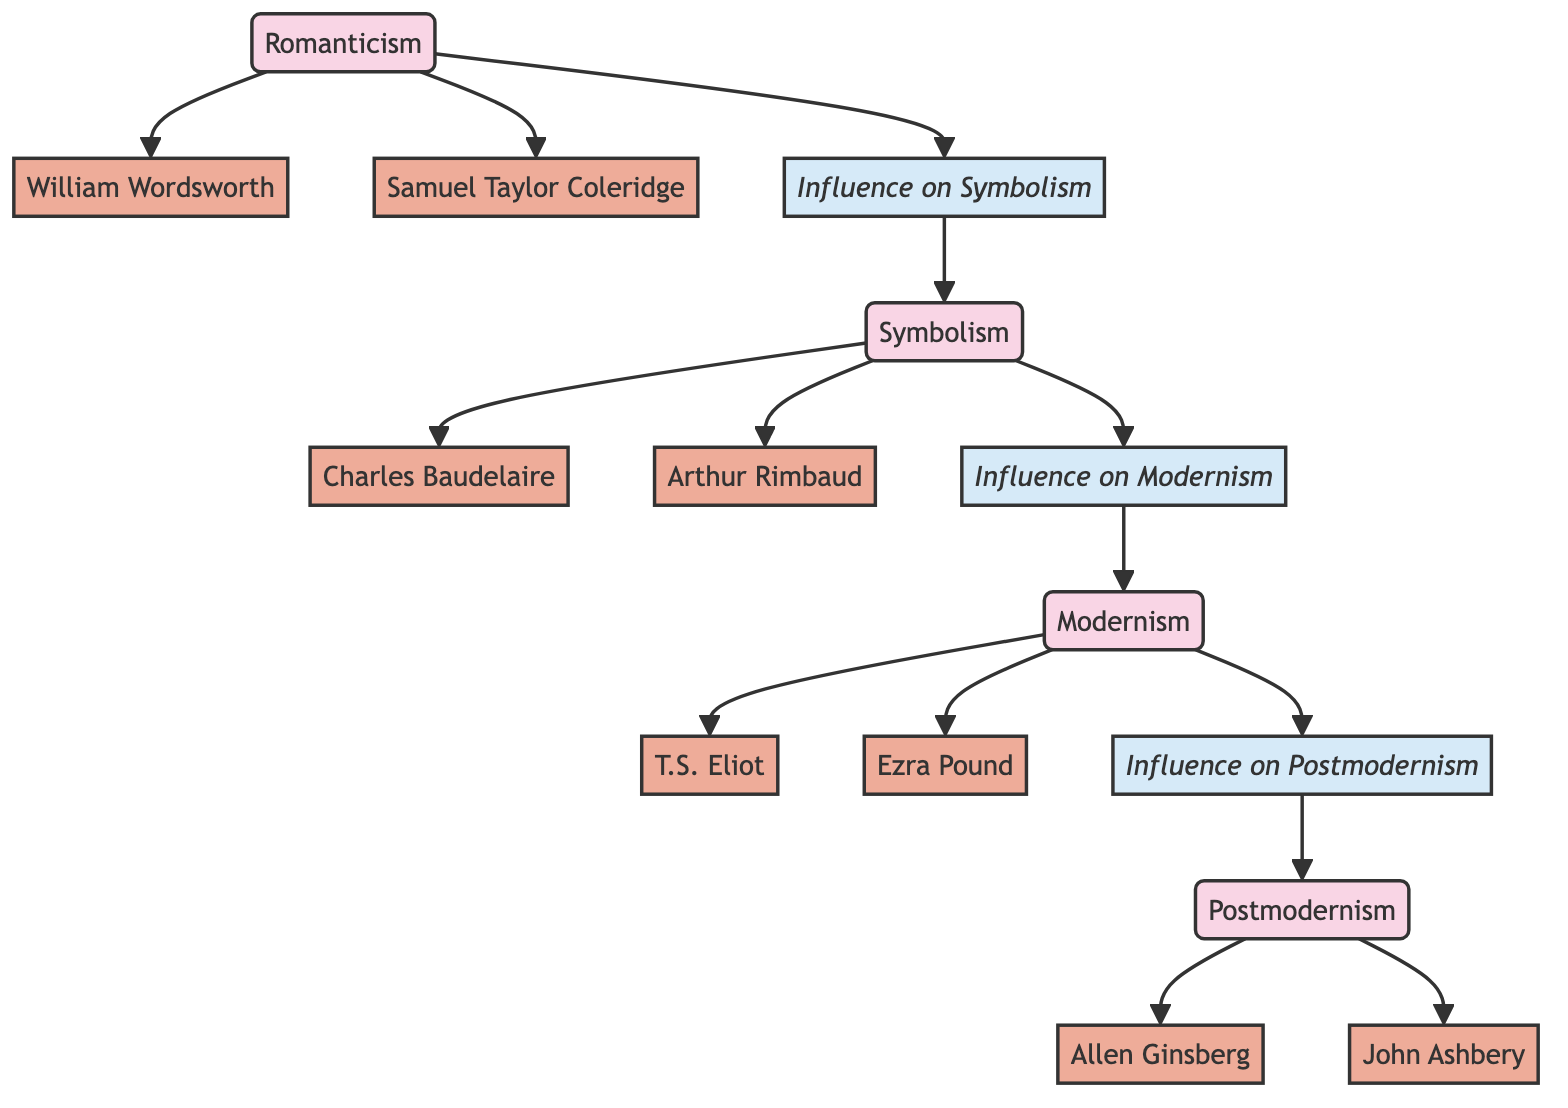What are the major literary movements shown in the diagram? The diagram includes four major literary movements: Romanticism, Symbolism, Modernism, and Postmodernism. These movements are nodes in the network, displayed separately, indicating their significance.
Answer: Romanticism, Symbolism, Modernism, Postmodernism Who are the poets associated with Romanticism? The poets linked directly to Romanticism in the diagram are William Wordsworth and Samuel Taylor Coleridge, shown as nodes connected to the Romanticism node.
Answer: William Wordsworth, Samuel Taylor Coleridge How many edges connect Symbolism to its influences? To determine the number of edges connecting Symbolism to its influences, we see that Symbolism has one edge connecting it to its influence on Modernism and two edges leading to the poets Baudelaire and Rimbaud. Therefore, there are three edges total.
Answer: 3 Which poet is connected to Modernism? T.S. Eliot and Ezra Pound are both connected to the Modernism node as they are directly linked with edges stemming from it.
Answer: T.S. Eliot, Ezra Pound What is the influence of Symbolism on Modernism? Symbolism influences Modernism as shown in the diagram with an edge labeled "Influence on Modernism" that connects the influence node to Modernism, signifying a direct social or artistic connection.
Answer: Influence on Modernism How many poets are connected to Postmodernism? The diagram shows two poets connected to Postmodernism: Allen Ginsberg and John Ashbery, both linked with edges from the Postmodernism node.
Answer: 2 Which movement directly follows Romanticism in the influence chain? In the influence chain represented in the diagram, Symbolism directly follows Romanticism as indicated by the edge labeled "Influence on Symbolism."
Answer: Symbolism Is there a link from Romanticism to Modernism? Analyzing the diagram reveals that there is no direct link from Romanticism to Modernism; instead, the influence flows through Symbolism, which connects to Modernism, indicating an indirect relationship.
Answer: No What is the total count of nodes and edges depicted in the diagram? The total number of nodes in the diagram is 15, representing both movements and poets, while there are 13 edges connecting them, indicating the relationships among these nodes.
Answer: 15 nodes, 13 edges 